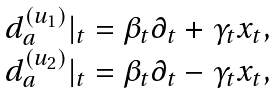<formula> <loc_0><loc_0><loc_500><loc_500>\begin{array} { r c } & d _ { a } ^ { ( u _ { 1 } ) } | _ { t } = \beta _ { t } \partial _ { t } + \gamma _ { t } x _ { t } , \\ & d _ { a } ^ { ( u _ { 2 } ) } | _ { t } = \beta _ { t } \partial _ { t } - \gamma _ { t } x _ { t } , \end{array}</formula> 